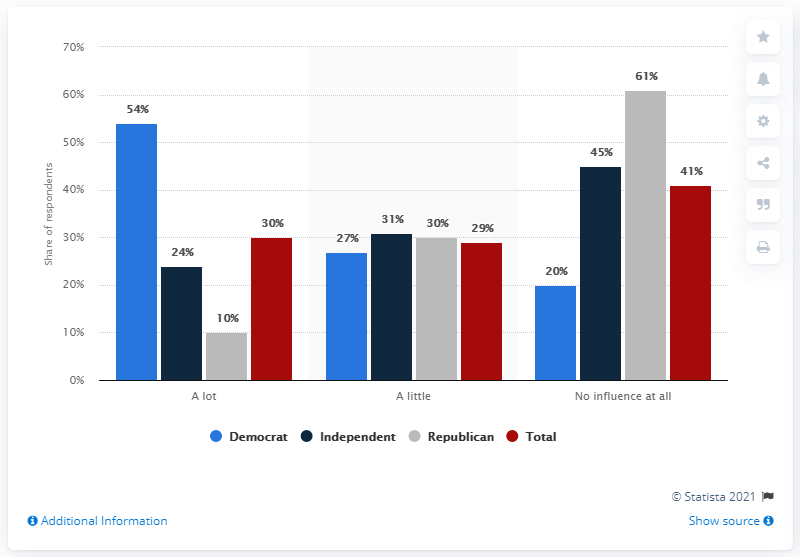Outline some significant characteristics in this image. A recent survey suggests that a significant percentage of Republicans believe that Trump is influenced by Fox News. 